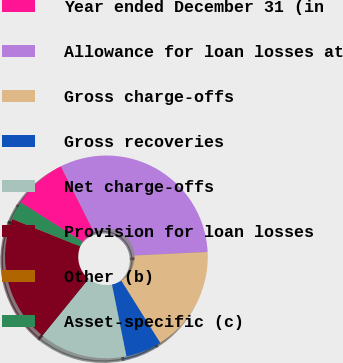Convert chart to OTSL. <chart><loc_0><loc_0><loc_500><loc_500><pie_chart><fcel>Year ended December 31 (in<fcel>Allowance for loan losses at<fcel>Gross charge-offs<fcel>Gross recoveries<fcel>Net charge-offs<fcel>Provision for loan losses<fcel>Other (b)<fcel>Asset-specific (c)<nl><fcel>8.59%<fcel>31.62%<fcel>16.88%<fcel>5.74%<fcel>14.03%<fcel>20.22%<fcel>0.03%<fcel>2.89%<nl></chart> 